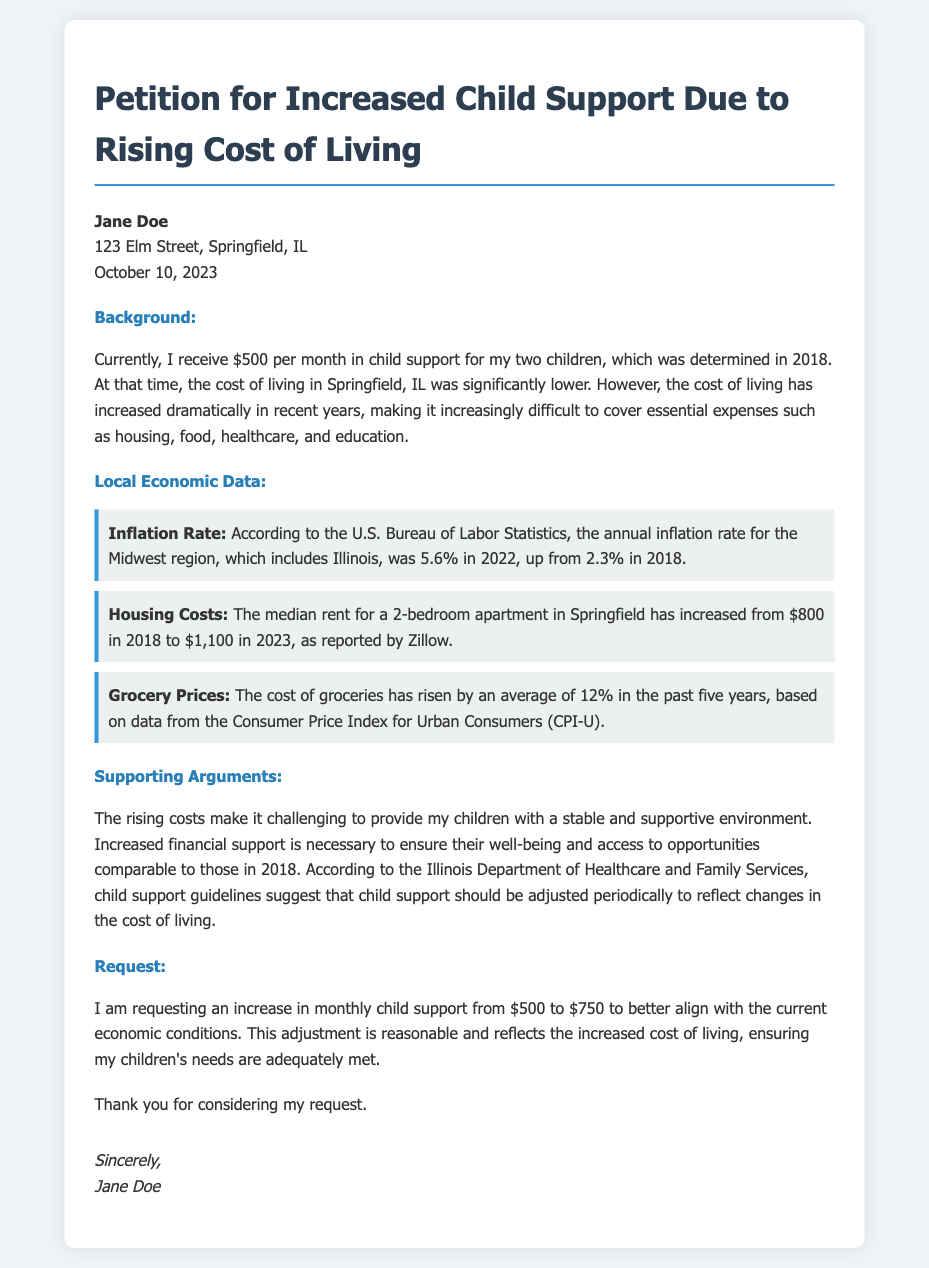What is the current monthly child support amount? The document states that the current monthly child support amount is $500.
Answer: $500 What year was the child support amount determined? The document mentions that the child support amount was determined in 2018.
Answer: 2018 What is the requested increase in child support? The document indicates that the requested increase in child support is from $500 to $750.
Answer: $750 What is the inflation rate for the Midwest region in 2022? According to the document, the annual inflation rate for the Midwest region in 2022 was 5.6%.
Answer: 5.6% What was the median rent for a 2-bedroom apartment in Springfield in 2018? The document mentions that the median rent for a 2-bedroom apartment in 2018 was $800.
Answer: $800 What does the Illinois Department of Healthcare and Family Services suggest about child support? The document states that they suggest child support should be adjusted periodically to reflect changes in the cost of living.
Answer: Adjusted periodically What is the main reason for requesting an increase in child support? The document explains that the increase is necessary to provide a stable and supportive environment for the children.
Answer: Stable and supportive environment How much has grocery prices risen on average in the past five years? The document claims that grocery prices have risen by an average of 12% in the past five years.
Answer: 12% What is the signature of the petitioner? The document shows that the petitioner’s name is Jane Doe.
Answer: Jane Doe 